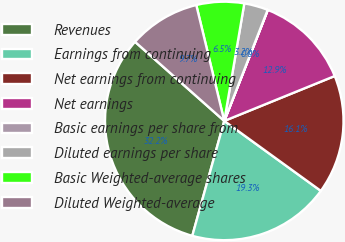Convert chart. <chart><loc_0><loc_0><loc_500><loc_500><pie_chart><fcel>Revenues<fcel>Earnings from continuing<fcel>Net earnings from continuing<fcel>Net earnings<fcel>Basic earnings per share from<fcel>Diluted earnings per share<fcel>Basic Weighted-average shares<fcel>Diluted Weighted-average<nl><fcel>32.22%<fcel>19.34%<fcel>16.12%<fcel>12.9%<fcel>0.02%<fcel>3.24%<fcel>6.46%<fcel>9.68%<nl></chart> 